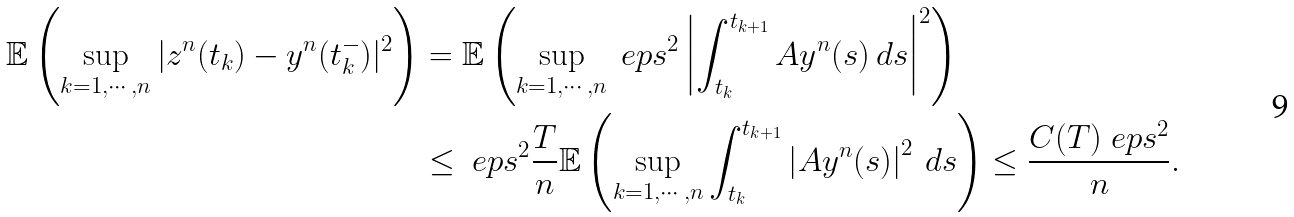Convert formula to latex. <formula><loc_0><loc_0><loc_500><loc_500>\mathbb { E } \left ( \sup _ { k = 1 , \cdots , n } | z ^ { n } ( t _ { k } ) - y ^ { n } ( t _ { k } ^ { - } ) | ^ { 2 } \right ) & = \mathbb { E } \left ( \sup _ { k = 1 , \cdots , n } \ e p s ^ { 2 } \left | \int _ { t _ { k } } ^ { t _ { k + 1 } } A y ^ { n } ( s ) \, d s \right | ^ { 2 } \right ) \\ & \leq \ e p s ^ { 2 } \frac { T } { n } \mathbb { E } \left ( \sup _ { k = 1 , \cdots , n } \int _ { t _ { k } } ^ { t _ { k + 1 } } \left | A y ^ { n } ( s ) \right | ^ { 2 } \, d s \right ) \leq \frac { C ( T ) \ e p s ^ { 2 } } { n } .</formula> 